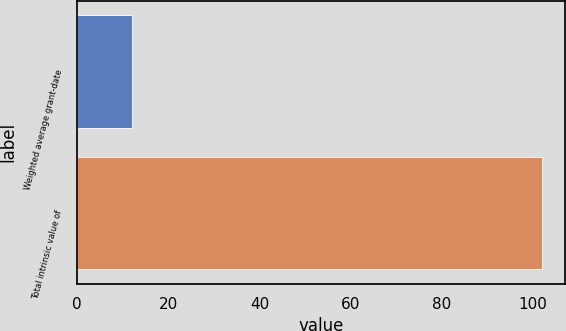Convert chart to OTSL. <chart><loc_0><loc_0><loc_500><loc_500><bar_chart><fcel>Weighted average grant-date<fcel>Total intrinsic value of<nl><fcel>12.08<fcel>102<nl></chart> 